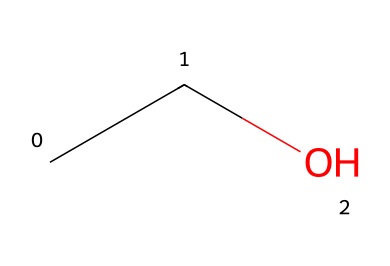How many carbon atoms are present in this chemical? The SMILES structure "CCO" directly indicates the presence of two carbon atoms ("C" represents carbon). Therefore, by counting the number of "C" characters, we find there are two.
Answer: two What type of bond connects the carbon atoms in this structure? In the SMILES notation, the two adjacent 'C' characters indicate a single bond, as there are no special notations for double or triple bonds present. Hence, the connection between the two carbon atoms is a single bond.
Answer: single bond What is the chemical name of this compound? The structure "CCO" represents ethanol, which is the common name for this compound as it consists of two carbons followed by an oxygen, indicating it is an alcohol.
Answer: ethanol What functional group is present in this compound? The presence of the "O" at the end of the SMILES indicates that the compound is an alcohol because "O" is part of the hydroxyl (-OH) functional group in which a hydroxyl group is attached to a carbon atom.
Answer: hydroxyl Is this compound aliphatic or aromatic? The structure shows a straight chain with no rings or delocalized electrons typical of aromatic compounds. Therefore, it is classified as an aliphatic compound, which is characterized by straight or branched chains.
Answer: aliphatic How many hydrogen atoms are in this compound? In the structure "CCO", each carbon atom is bonded to enough hydrogen atoms to satisfy carbon's tetravalency. With two carbons and one oxygen, the molecular formula is C2H6O, indicating there are six hydrogen atoms.
Answer: six Does this compound have potential use in religious practices? Ethanol, the compound represented by this SMILES, is commonly used in Catholic communion wine as it is the principal type of alcohol used. Therefore, its application in this context is significant.
Answer: yes 